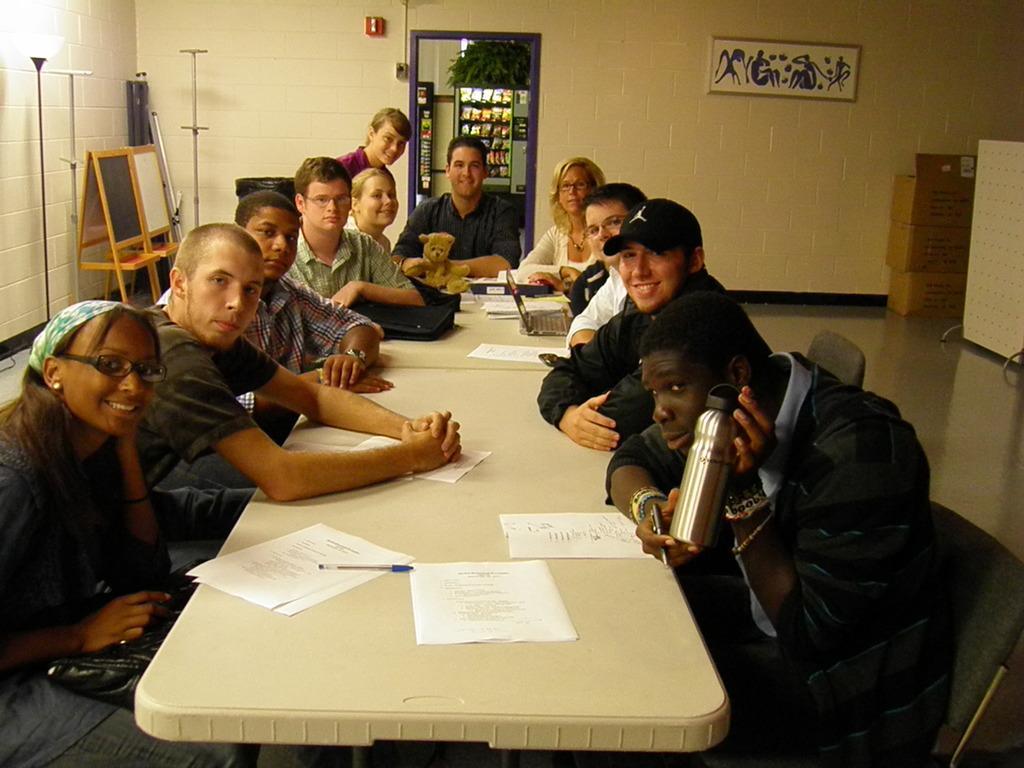Please provide a concise description of this image. In this picture we can see some group of people sitting on the chairs around the table on which there are some papers, doll and laptop and behind them there is a door and a desk and a stands. 